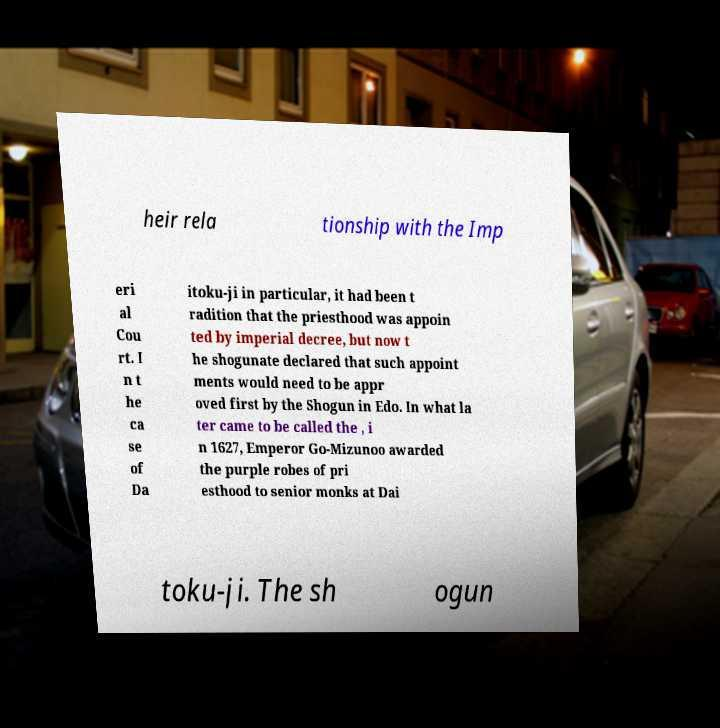Could you extract and type out the text from this image? heir rela tionship with the Imp eri al Cou rt. I n t he ca se of Da itoku-ji in particular, it had been t radition that the priesthood was appoin ted by imperial decree, but now t he shogunate declared that such appoint ments would need to be appr oved first by the Shogun in Edo. In what la ter came to be called the , i n 1627, Emperor Go-Mizunoo awarded the purple robes of pri esthood to senior monks at Dai toku-ji. The sh ogun 